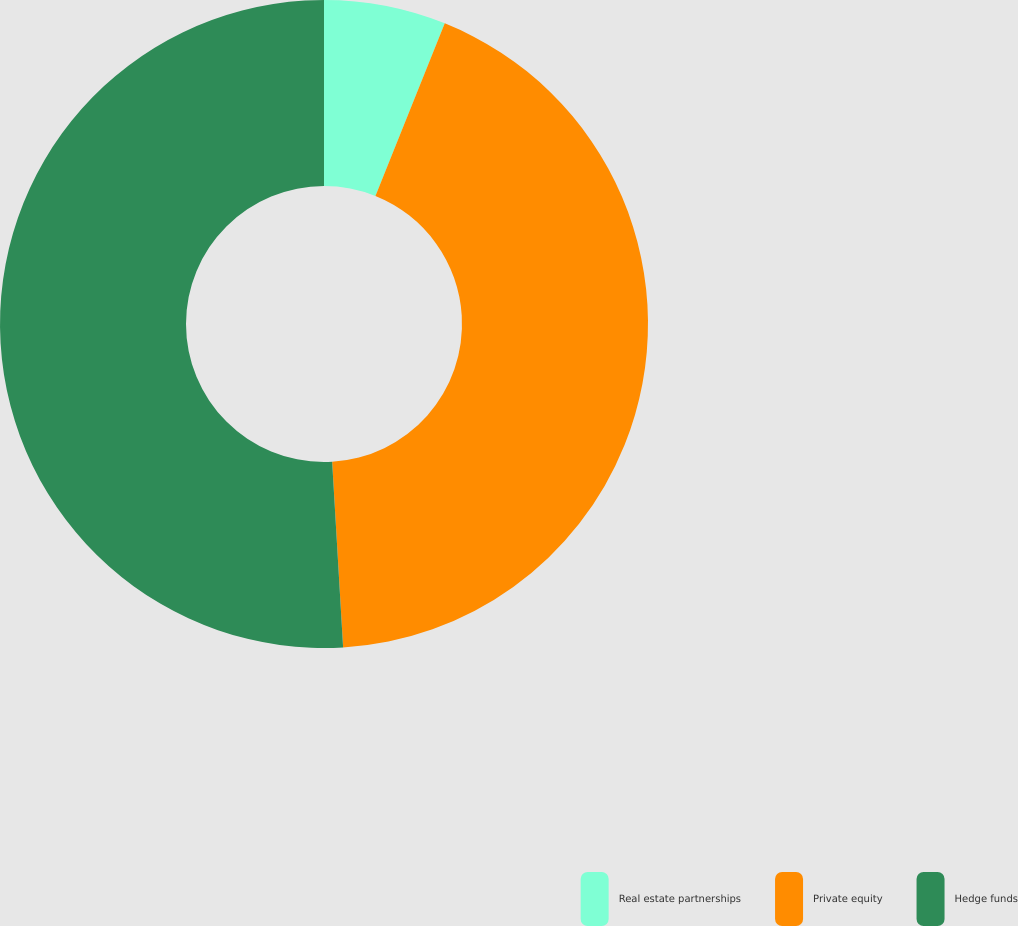Convert chart to OTSL. <chart><loc_0><loc_0><loc_500><loc_500><pie_chart><fcel>Real estate partnerships<fcel>Private equity<fcel>Hedge funds<nl><fcel>6.08%<fcel>42.98%<fcel>50.94%<nl></chart> 